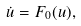<formula> <loc_0><loc_0><loc_500><loc_500>\dot { u } = F _ { 0 } ( u ) ,</formula> 